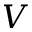<formula> <loc_0><loc_0><loc_500><loc_500>V</formula> 